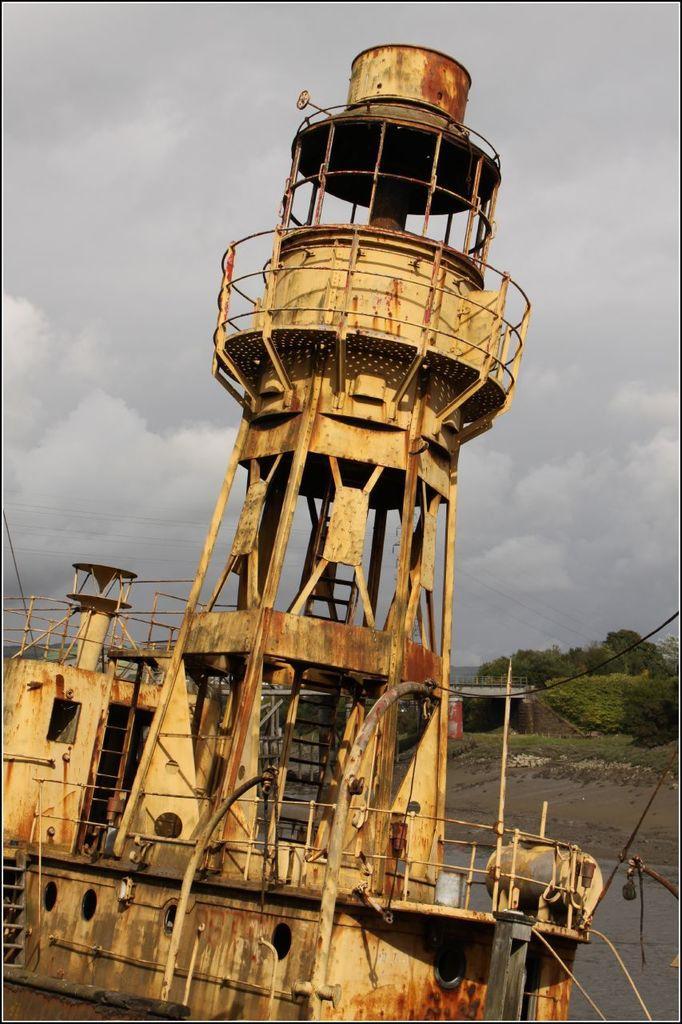In one or two sentences, can you explain what this image depicts? In the image there is a rusty boat in the lake with trees behind it and above its sky. 